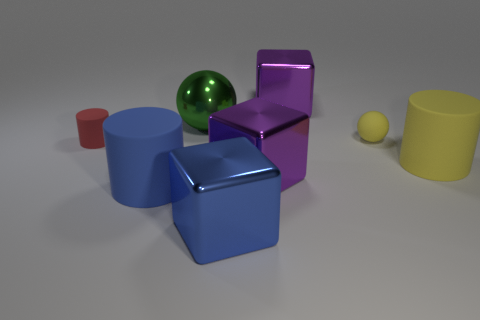Subtract 1 cylinders. How many cylinders are left? 2 Subtract all big blue metal blocks. How many blocks are left? 2 Add 1 tiny yellow matte objects. How many objects exist? 9 Subtract all blocks. How many objects are left? 5 Add 3 green things. How many green things exist? 4 Subtract 0 red blocks. How many objects are left? 8 Subtract all yellow spheres. Subtract all red cylinders. How many objects are left? 6 Add 6 rubber objects. How many rubber objects are left? 10 